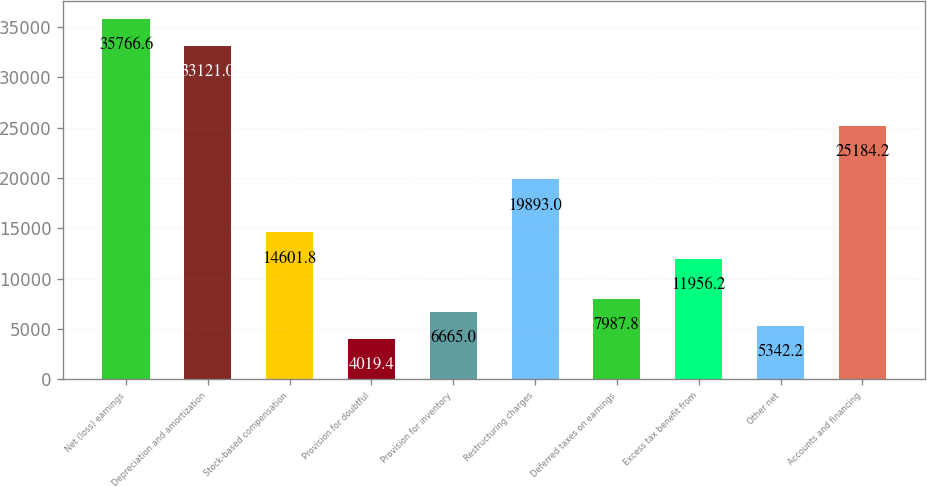Convert chart. <chart><loc_0><loc_0><loc_500><loc_500><bar_chart><fcel>Net (loss) earnings<fcel>Depreciation and amortization<fcel>Stock-based compensation<fcel>Provision for doubtful<fcel>Provision for inventory<fcel>Restructuring charges<fcel>Deferred taxes on earnings<fcel>Excess tax benefit from<fcel>Other net<fcel>Accounts and financing<nl><fcel>35766.6<fcel>33121<fcel>14601.8<fcel>4019.4<fcel>6665<fcel>19893<fcel>7987.8<fcel>11956.2<fcel>5342.2<fcel>25184.2<nl></chart> 